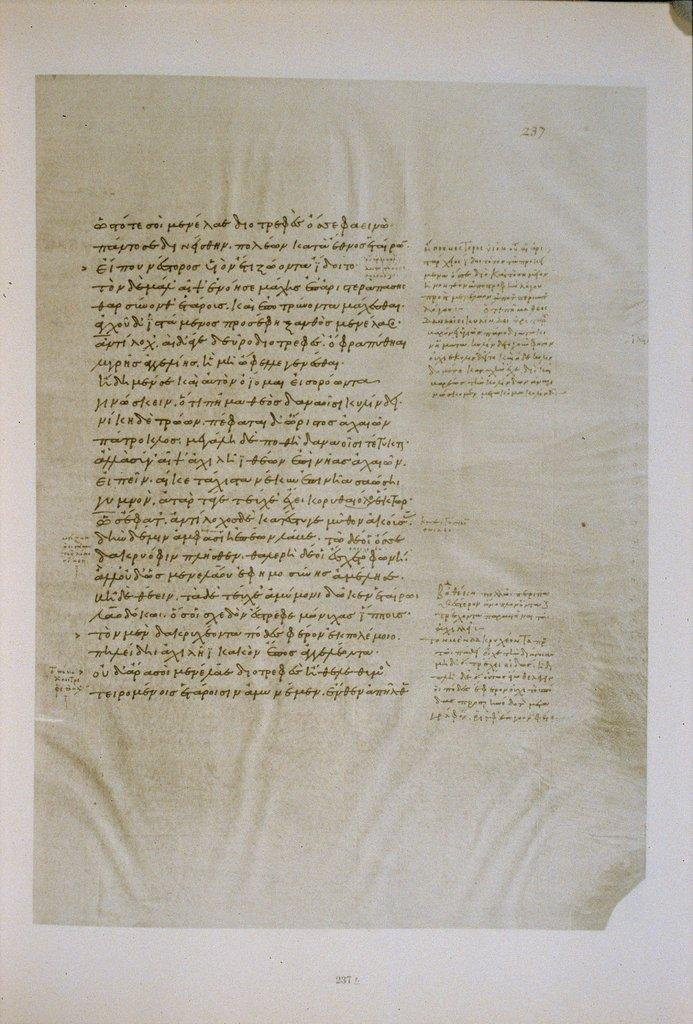<image>
Offer a succinct explanation of the picture presented. A single page is laid out on a white surface and numbered page 237. 